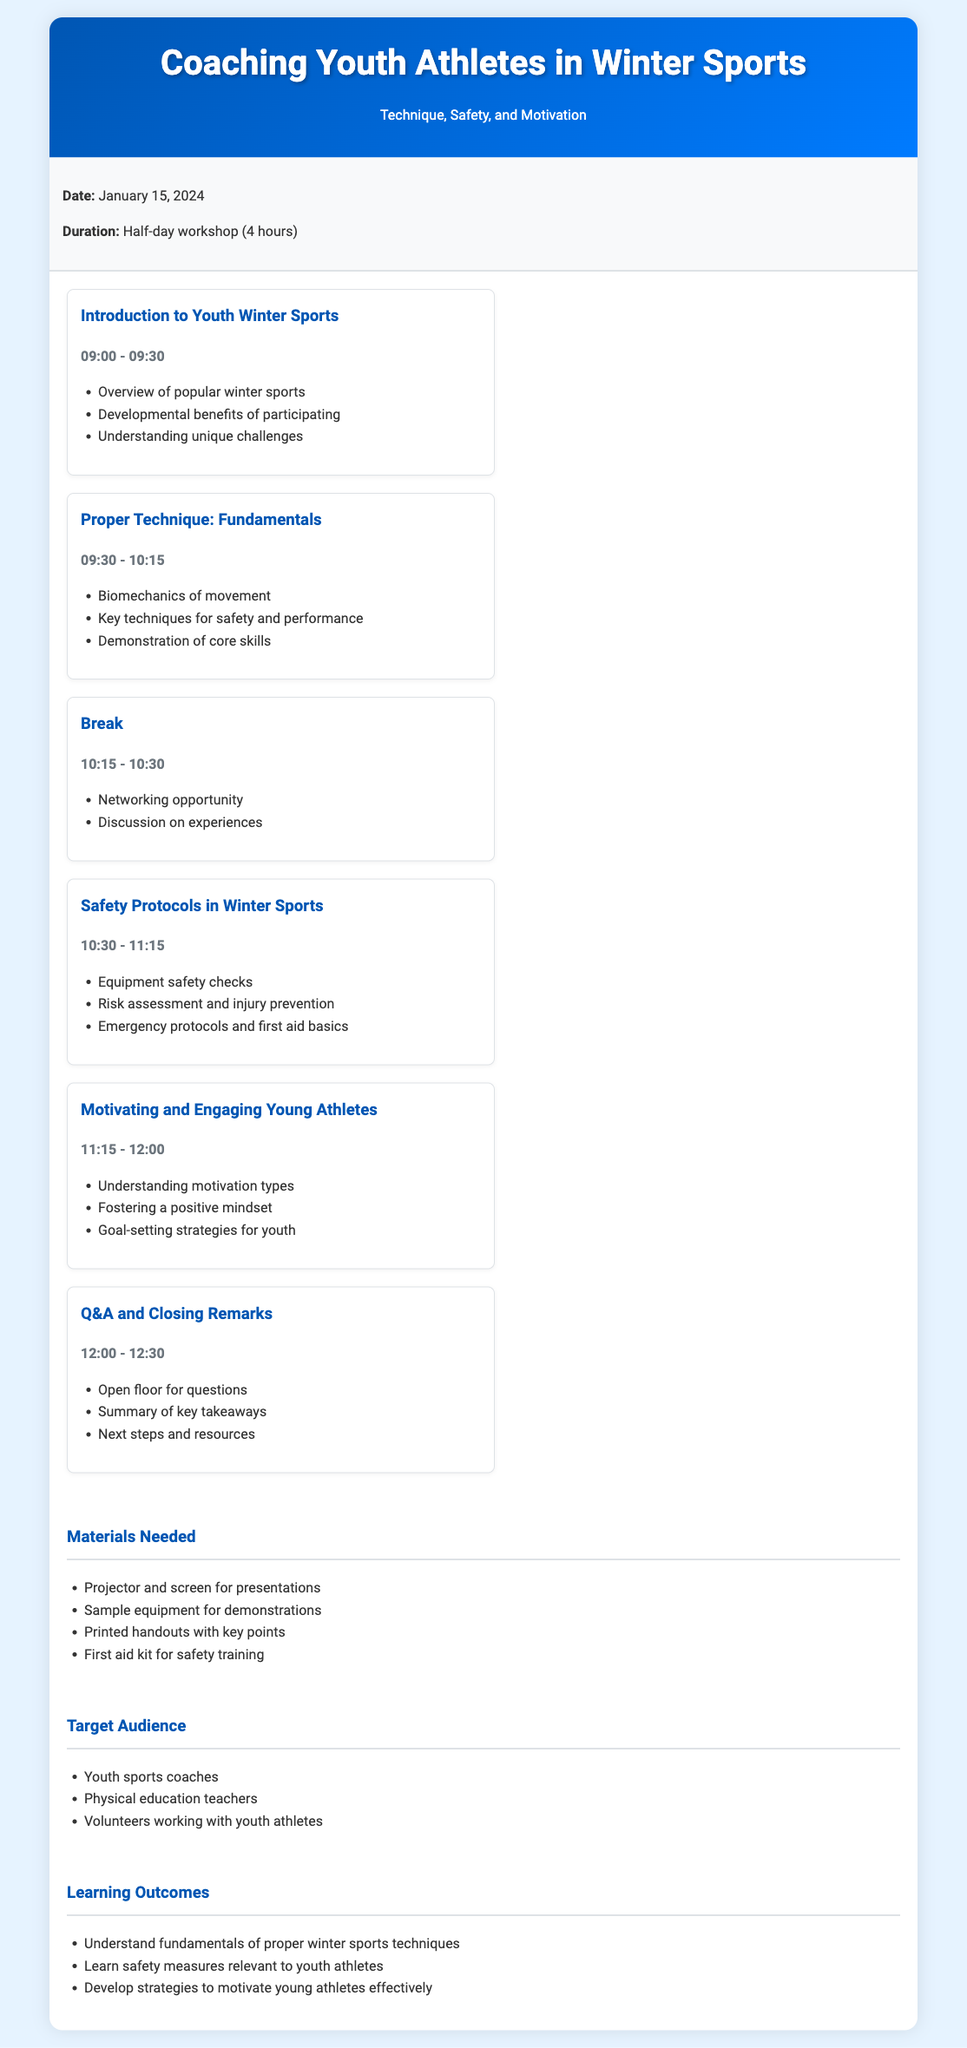What is the date of the workshop? The date of the workshop is explicitly stated in the workshop information section of the document.
Answer: January 15, 2024 What is the duration of the workshop? The duration is mentioned in the workshop information section, specifying how long the event will last.
Answer: Half-day workshop (4 hours) What are the first two topics of the agenda? The agenda lists out the sessions in order; the first two topics are highlighted clearly.
Answer: Introduction to Youth Winter Sports, Proper Technique: Fundamentals Which session focuses on safety protocols? The session titles in the agenda indicate the focus areas, and the title of the relevant session provides the answer.
Answer: Safety Protocols in Winter Sports What is one objective of the workshop? The learning outcomes at the end of the document summarize key objectives aimed at participants.
Answer: Understand fundamentals of proper winter sports techniques Who is the target audience for the workshop? The document specifies the intended audience group for this workshop in the target audience section.
Answer: Youth sports coaches When does the Q&A and closing remarks session start? The start time for each session is listed; thus, the time for this particular session can be found easily.
Answer: 12:00 What type of materials are needed for the workshop? The materials section details what will be required, including equipment and resources for the workshop.
Answer: Projector and screen for presentations How long is the break scheduled for? The break details are outlined in the agenda along with its timing.
Answer: 15 minutes 